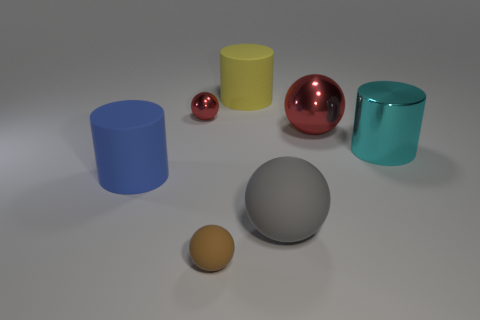Subtract all yellow spheres. Subtract all red cubes. How many spheres are left? 4 Add 1 large gray shiny things. How many objects exist? 8 Subtract all cylinders. How many objects are left? 4 Subtract all small brown spheres. Subtract all yellow cylinders. How many objects are left? 5 Add 6 large yellow objects. How many large yellow objects are left? 7 Add 4 big rubber cylinders. How many big rubber cylinders exist? 6 Subtract 1 cyan cylinders. How many objects are left? 6 